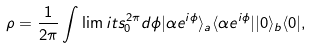Convert formula to latex. <formula><loc_0><loc_0><loc_500><loc_500>\rho = \frac { 1 } { 2 \pi } \int \lim i t s _ { 0 } ^ { 2 \pi } d \phi | \alpha e ^ { i \phi } \rangle _ { a } \langle \alpha e ^ { i \phi } | | 0 \rangle _ { b } \langle 0 | ,</formula> 